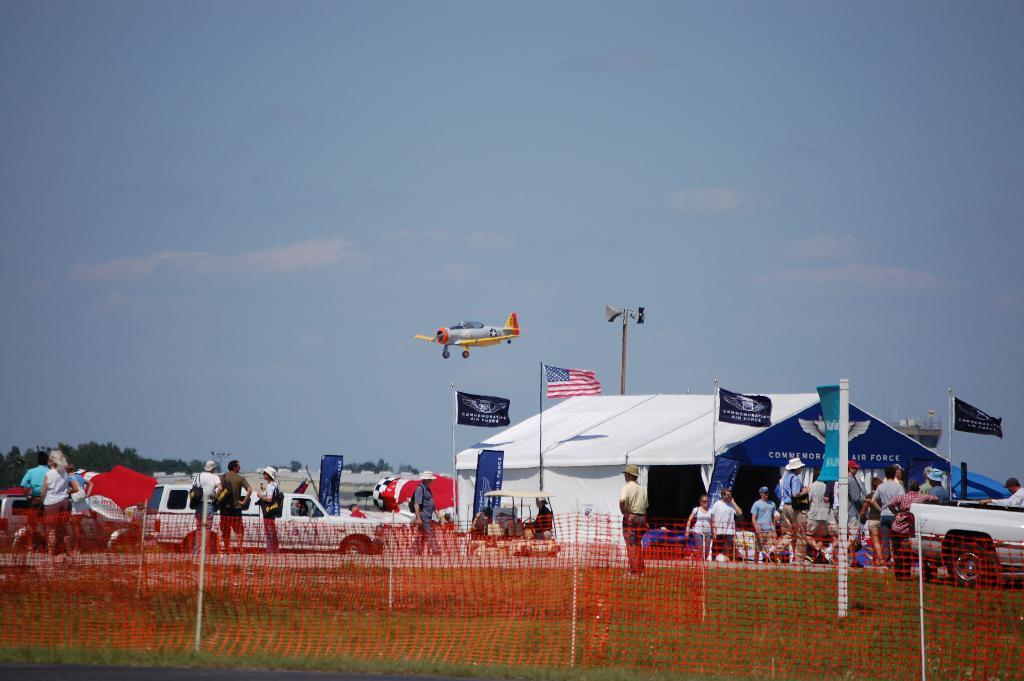Who or what can be seen in the image? There are people and vehicles in the image. What structure is present in the image? There is a shed in the image. What is attached to the shed? There are flags around the shed. What object is visible in the image that can be used for catching or holding? There is a net in the image. What type of vegetation is present in the image? There is grass in the image. What type of transportation is visible in the image? There is an aircraft in the image. What part of the natural environment is visible in the image? The sky is visible in the image. What type of throat can be seen in the image? There is no throat present in the image. What type of plantation can be seen in the image? There is no plantation present in the image. 